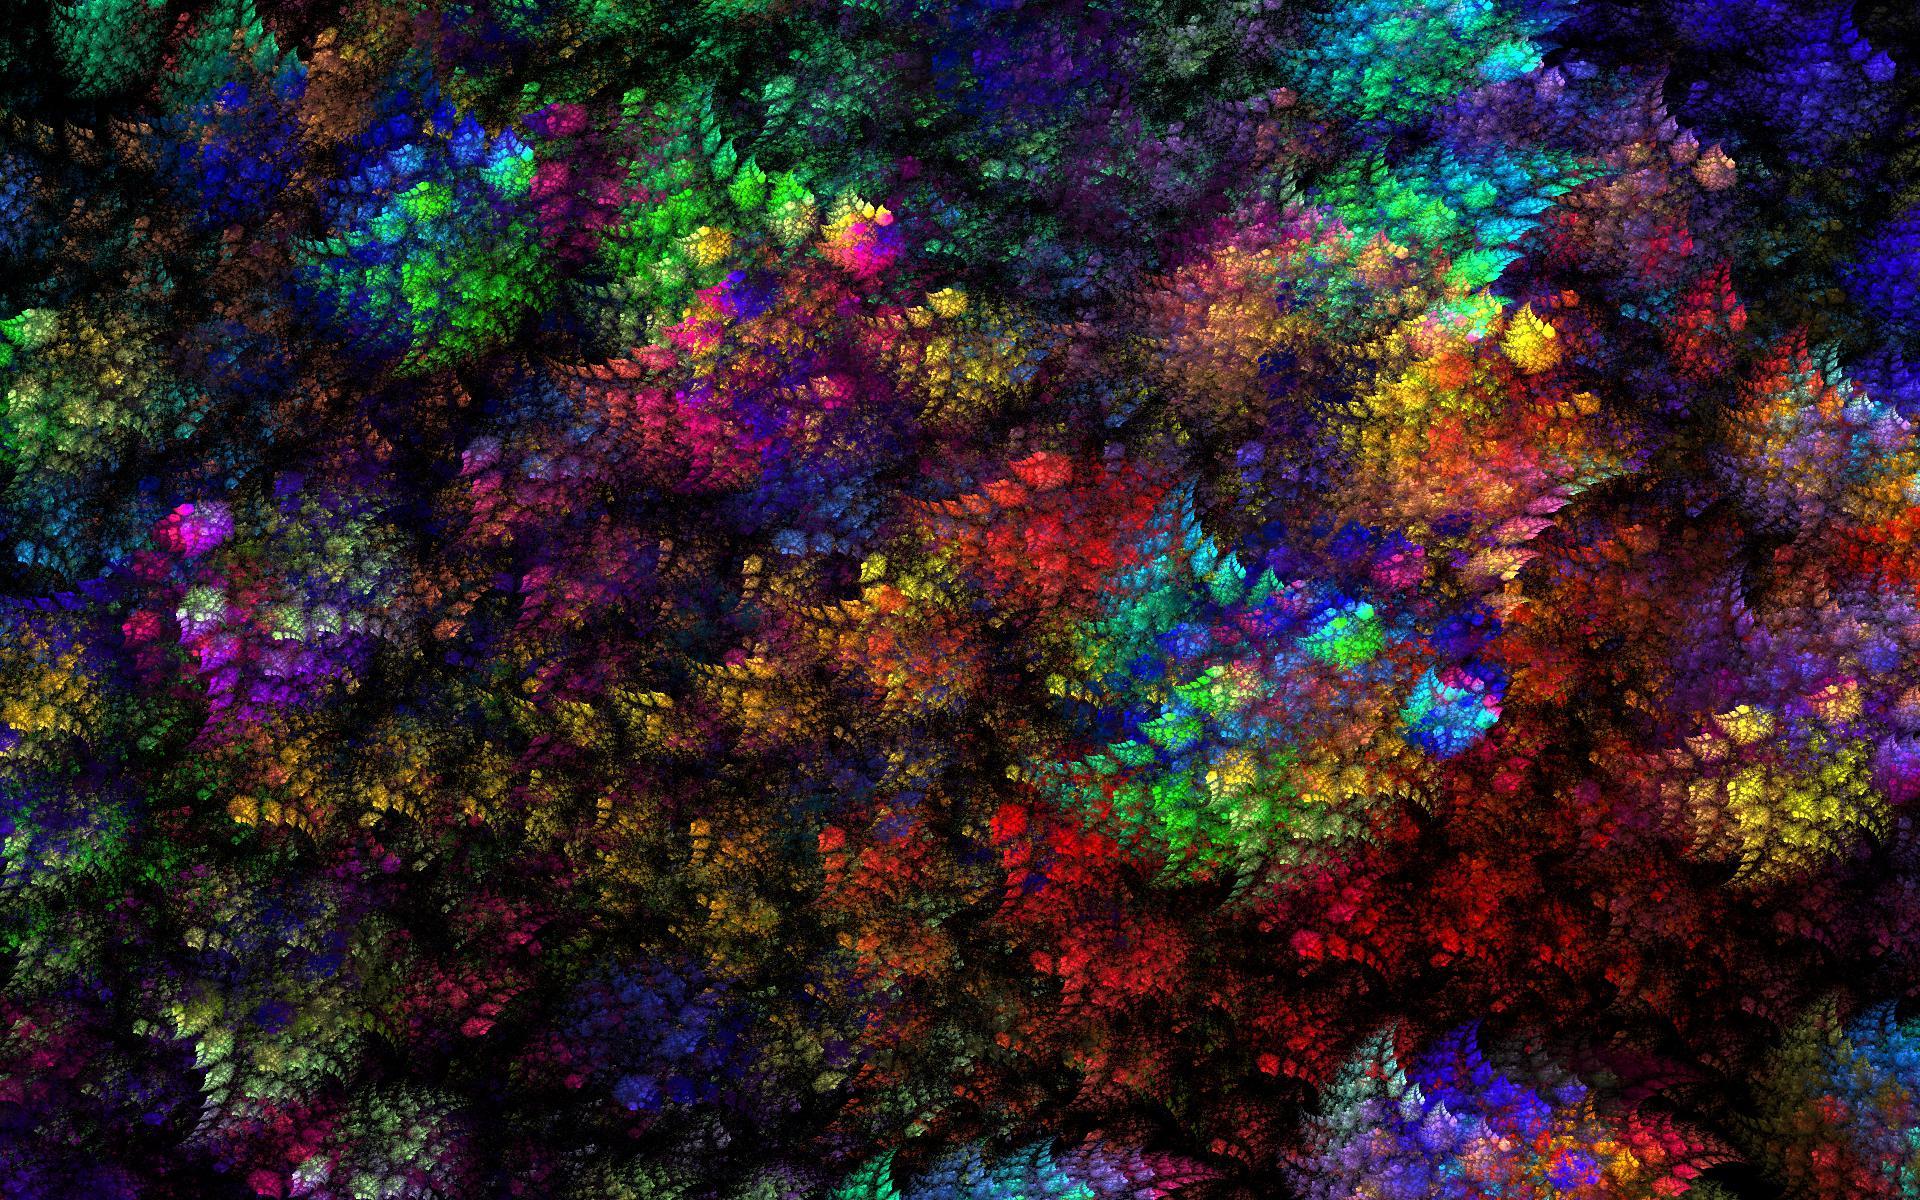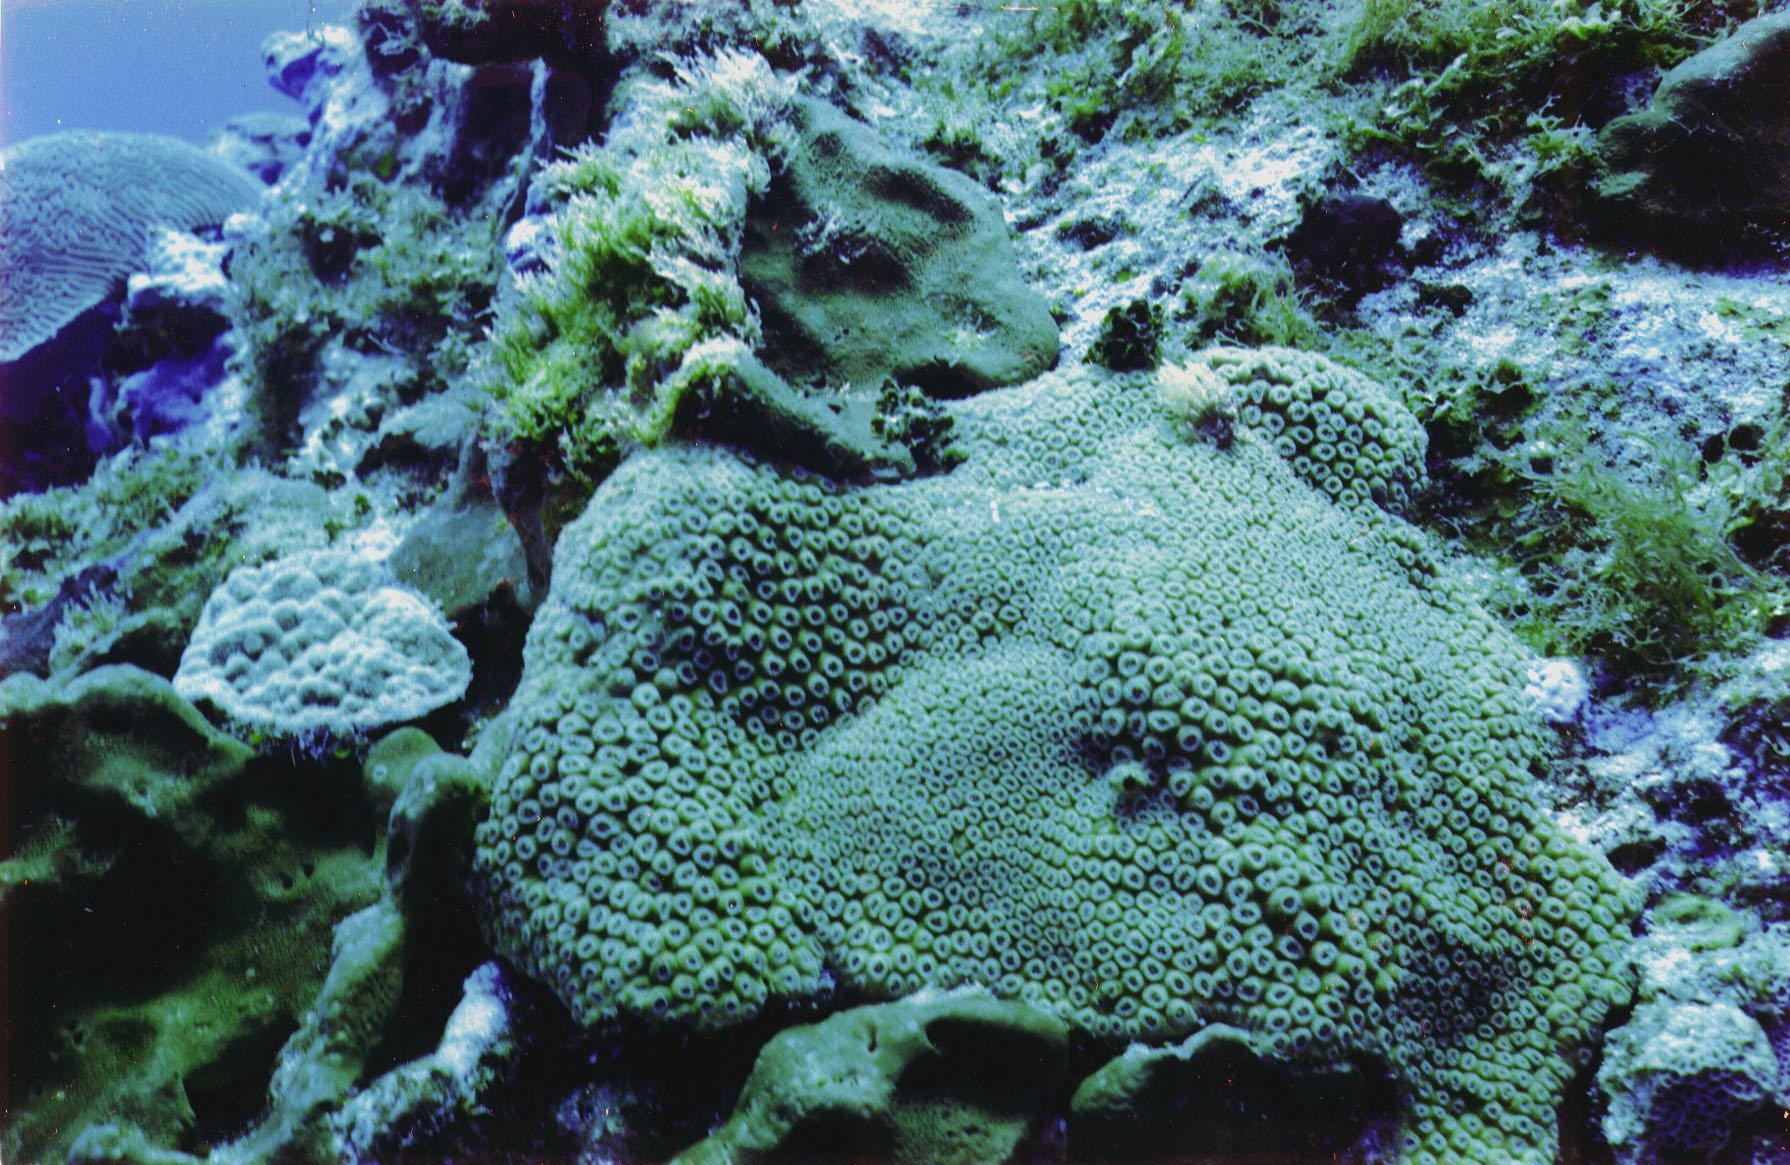The first image is the image on the left, the second image is the image on the right. For the images shown, is this caption "IN at least one image there is at least 10 circled yellow and brown corral  arms facing forward." true? Answer yes or no. No. The first image is the image on the left, the second image is the image on the right. Given the left and right images, does the statement "One image shows a mass of flower-shaped anemone with flatter white centers surrounded by slender tendrils." hold true? Answer yes or no. No. 